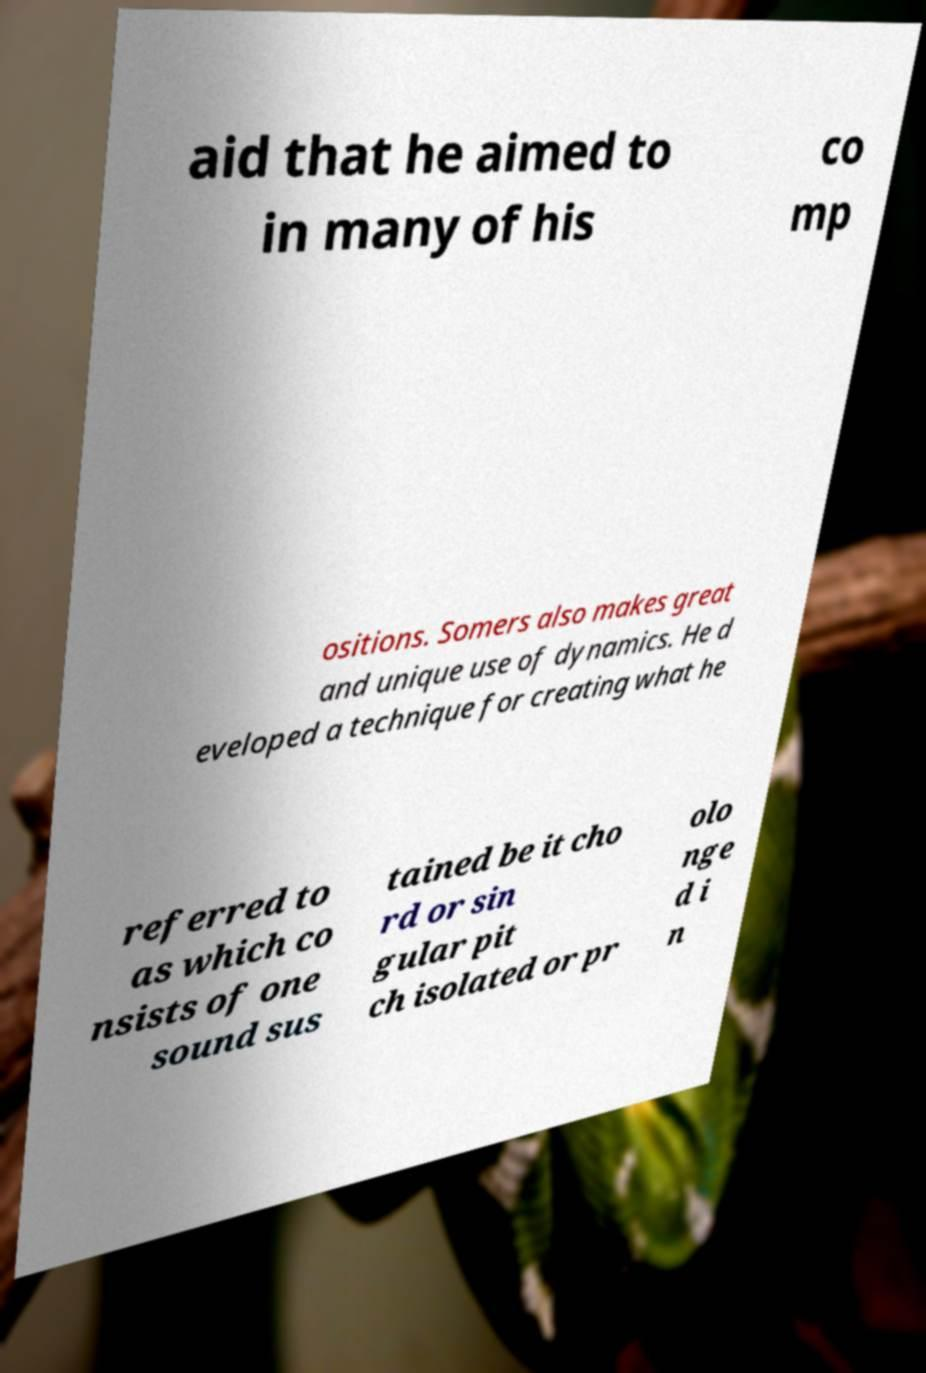Could you extract and type out the text from this image? aid that he aimed to in many of his co mp ositions. Somers also makes great and unique use of dynamics. He d eveloped a technique for creating what he referred to as which co nsists of one sound sus tained be it cho rd or sin gular pit ch isolated or pr olo nge d i n 